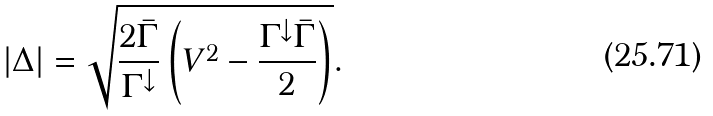<formula> <loc_0><loc_0><loc_500><loc_500>| \Delta | = \sqrt { \frac { 2 \bar { \Gamma } } { \Gamma ^ { \downarrow } } \left ( V ^ { 2 } - \frac { \Gamma ^ { \downarrow } \bar { \Gamma } } { 2 } \right ) } .</formula> 